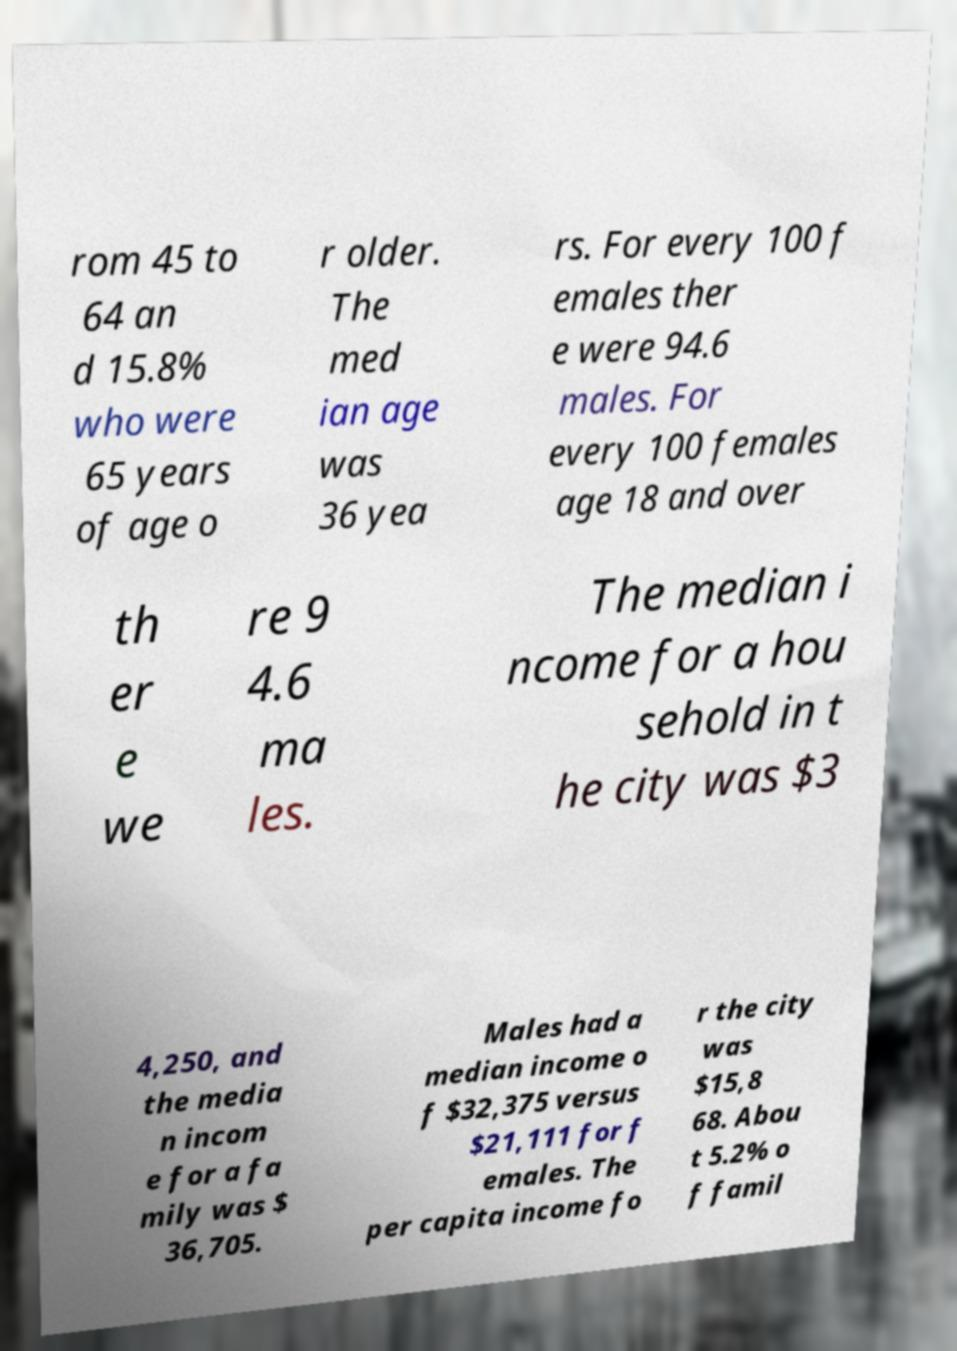Could you extract and type out the text from this image? rom 45 to 64 an d 15.8% who were 65 years of age o r older. The med ian age was 36 yea rs. For every 100 f emales ther e were 94.6 males. For every 100 females age 18 and over th er e we re 9 4.6 ma les. The median i ncome for a hou sehold in t he city was $3 4,250, and the media n incom e for a fa mily was $ 36,705. Males had a median income o f $32,375 versus $21,111 for f emales. The per capita income fo r the city was $15,8 68. Abou t 5.2% o f famil 